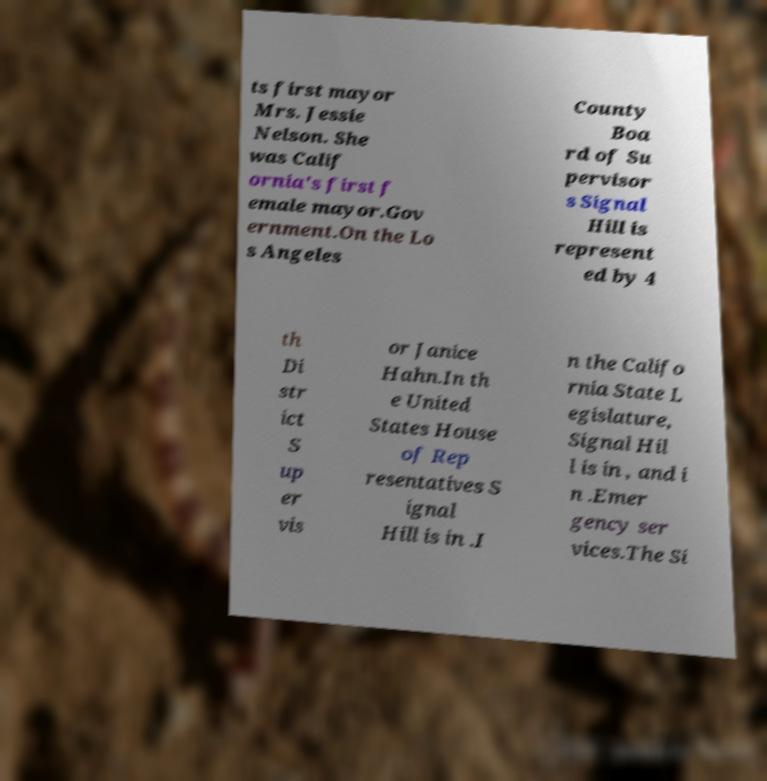Can you accurately transcribe the text from the provided image for me? ts first mayor Mrs. Jessie Nelson. She was Calif ornia's first f emale mayor.Gov ernment.On the Lo s Angeles County Boa rd of Su pervisor s Signal Hill is represent ed by 4 th Di str ict S up er vis or Janice Hahn.In th e United States House of Rep resentatives S ignal Hill is in .I n the Califo rnia State L egislature, Signal Hil l is in , and i n .Emer gency ser vices.The Si 